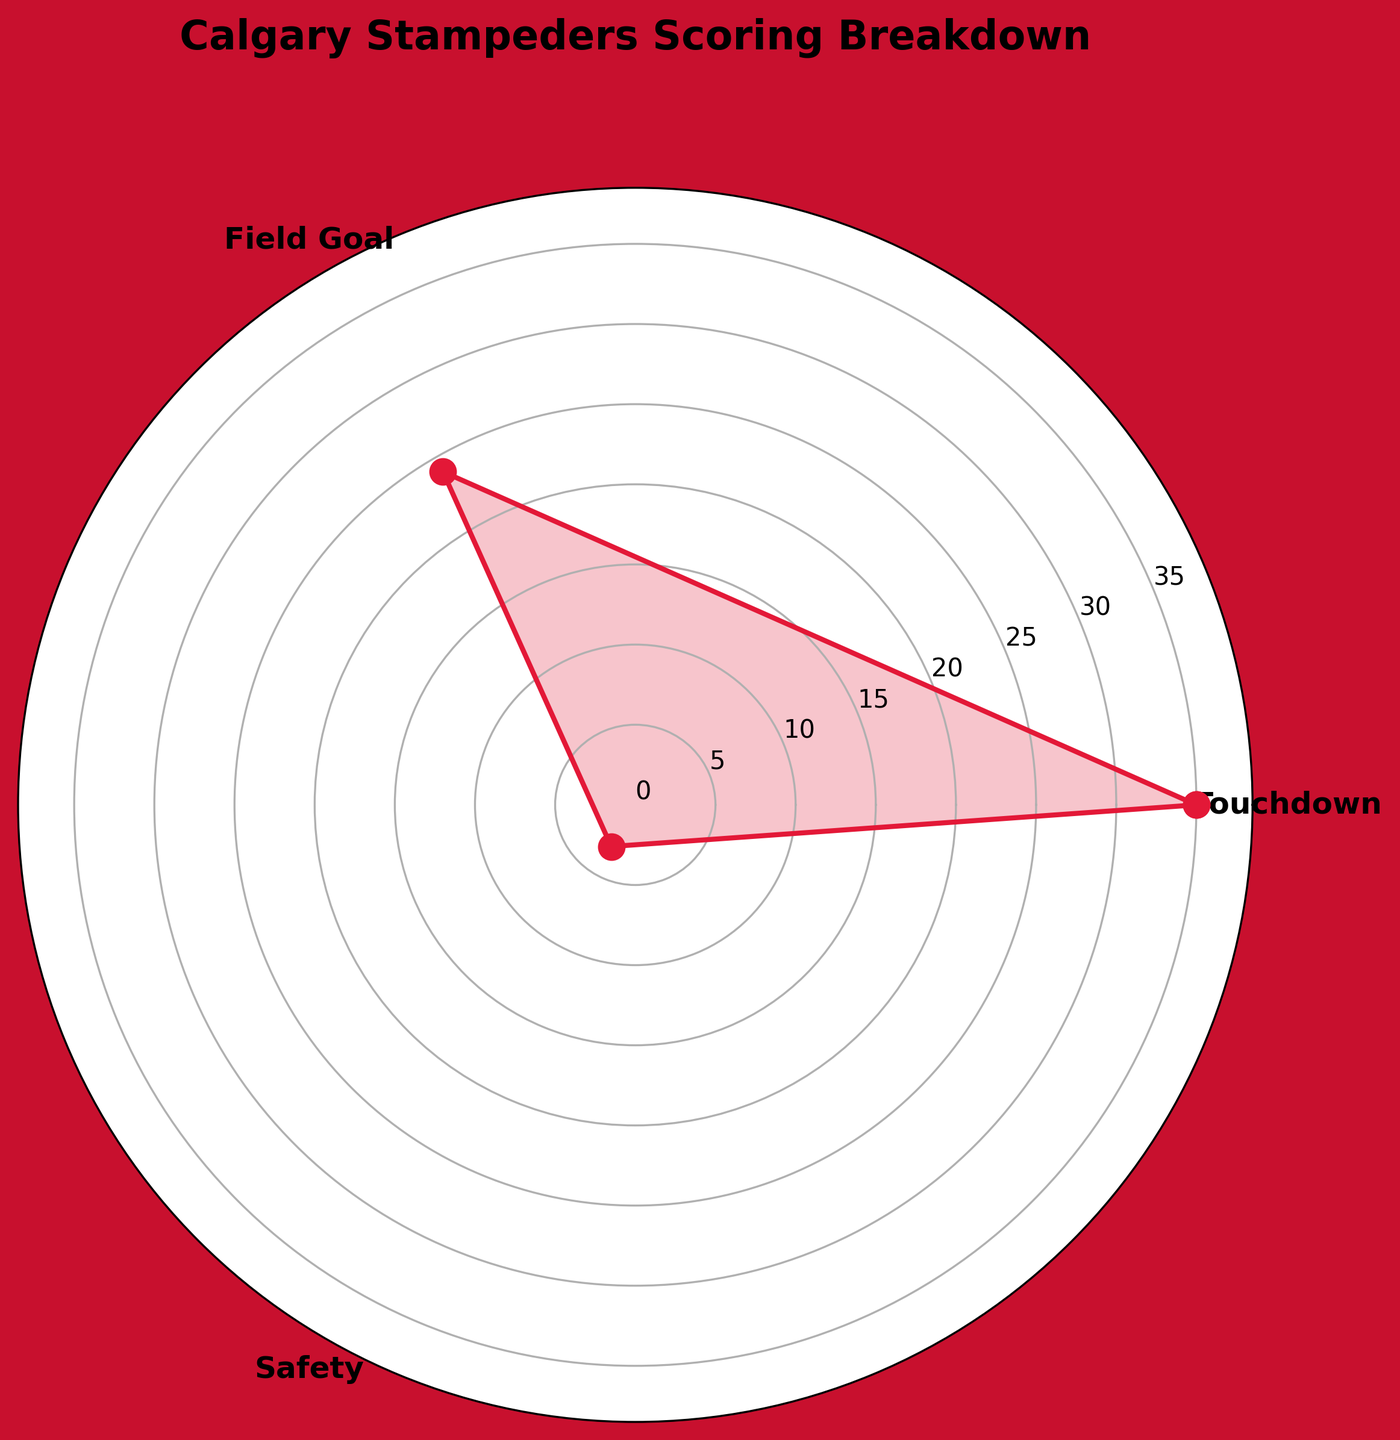what is the highest number of scoring methods among the groups? Based on the figure, we can see that touchdowns have the highest value at 35. By identifying the tallest segment in the rose chart, we determine that the highest number of scoring methods is for touchdowns.
Answer: 35 which scoring method has the lowest count? Observing the rose chart, the shortest segment represents the safety group. The numerical value indicated for safeties is 3, which is the lowest among the given scoring methods.
Answer: Safety what is the total count of all scoring methods combined? By summing up all the counts from the groups: touchdowns (35), field goals (24), and safeties (3), we get the total number of scoring methods: 35 + 24 + 3 = 62.
Answer: 62 how much more touchdowns are there than safeties? To find how many more touchdowns there are compared to safeties, subtract the count of safeties (3) from the count of touchdowns (35): 35 - 3 = 32.
Answer: 32 how is the breakdown of scoring methods visually differentiated in the chart? By looking at the rose chart, we can see different marker sizes, line fills, and separate titled segments for each scoring method. The categories are labeled around the plot, clearly differentiating between touchdowns, field goals, and safeties. Moreover, the visual elements such as shaded areas and marker lines distinctly separate the chart into different sections.
Answer: distinct segments and shading what percentage of the total scoring methods are field goals? First, we calculate the total count of scoring methods (62). The count for field goals is 24. The percentage is calculated as (24 / 62) * 100. Therefore, (24 / 62) * 100 ≈ 38.71%.
Answer: 38.71% are there more than 20 field goals? The figure shows a tall segment for field goals with a value of 24, which is clearly more than 20.
Answer: Yes how is the title of the rose chart presented? The title "Calgary Stampeders Scoring Breakdown" is presented at the top of the chart in bold and larger font. It is visually prominent and centered above the main part of the rose chart.
Answer: Calgary Stampeders Scoring Breakdown what is the difference between the counts of touchdowns and field goals? By subtracting the count of field goals (24) from the count of touchdowns (35), we find the difference: 35 - 24 = 11.
Answer: 11 